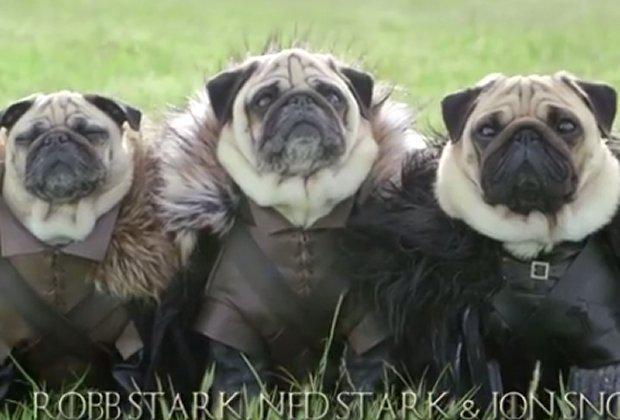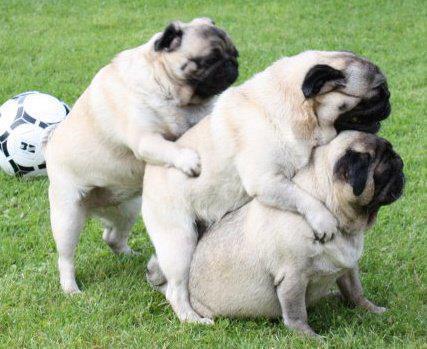The first image is the image on the left, the second image is the image on the right. Evaluate the accuracy of this statement regarding the images: "One image shows three pugs posed like a conga line, two of them facing another's back with front paws around its midsection.". Is it true? Answer yes or no. Yes. The first image is the image on the left, the second image is the image on the right. Examine the images to the left and right. Is the description "Three dogs are in a row, shoulder to shoulder in one of the images." accurate? Answer yes or no. Yes. 